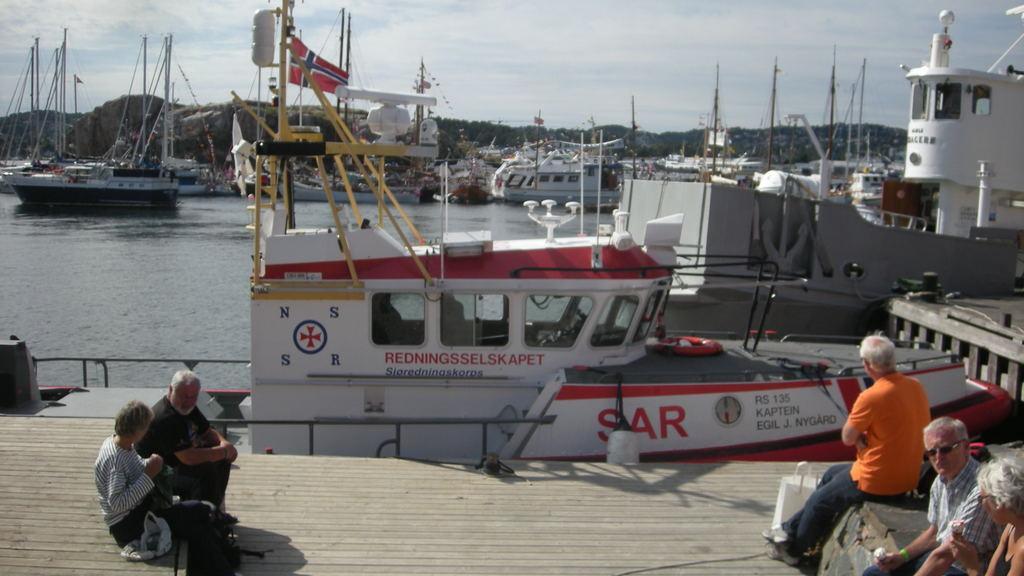How would you summarize this image in a sentence or two? In the foreground of this image, on the right, there are three persons sitting and two are holding ice creams. On the left, there is a bag and two persons are on the wooden surface. In the background, there are boats and ships on the water, mountains, sky and the cloud. 